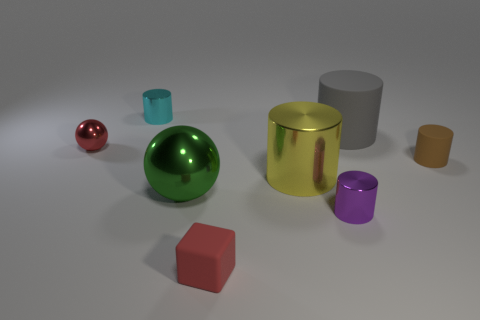Is the color of the large metallic thing to the right of the tiny block the same as the tiny block?
Keep it short and to the point. No. What number of balls are either red things or tiny red metal objects?
Keep it short and to the point. 1. What is the size of the shiny cylinder that is behind the small matte cylinder that is right of the small cylinder in front of the brown matte cylinder?
Offer a very short reply. Small. What is the shape of the red rubber thing that is the same size as the purple metallic cylinder?
Ensure brevity in your answer.  Cube. What is the shape of the red rubber object?
Keep it short and to the point. Cube. Is the material of the tiny red thing left of the small red cube the same as the green sphere?
Provide a succinct answer. Yes. What size is the red matte object in front of the tiny cylinder that is in front of the large ball?
Your answer should be compact. Small. There is a small object that is both on the left side of the small purple cylinder and in front of the large green ball; what color is it?
Offer a very short reply. Red. What is the material of the yellow cylinder that is the same size as the green metallic object?
Your response must be concise. Metal. How many other things are made of the same material as the red cube?
Your answer should be compact. 2. 